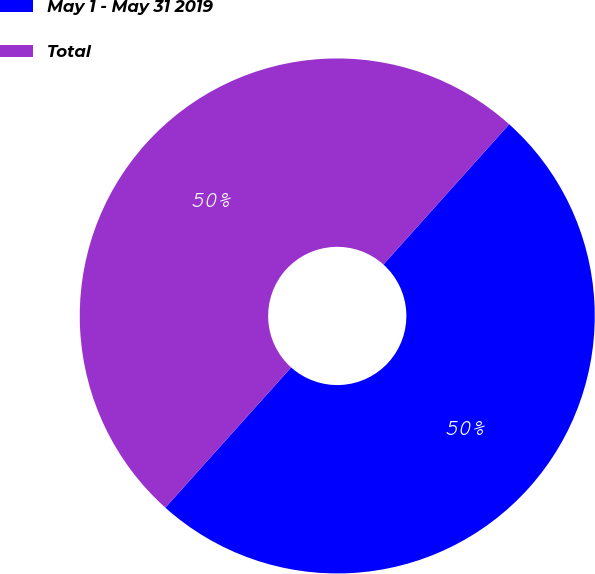<chart> <loc_0><loc_0><loc_500><loc_500><pie_chart><fcel>May 1 - May 31 2019<fcel>Total<nl><fcel>50.0%<fcel>50.0%<nl></chart> 